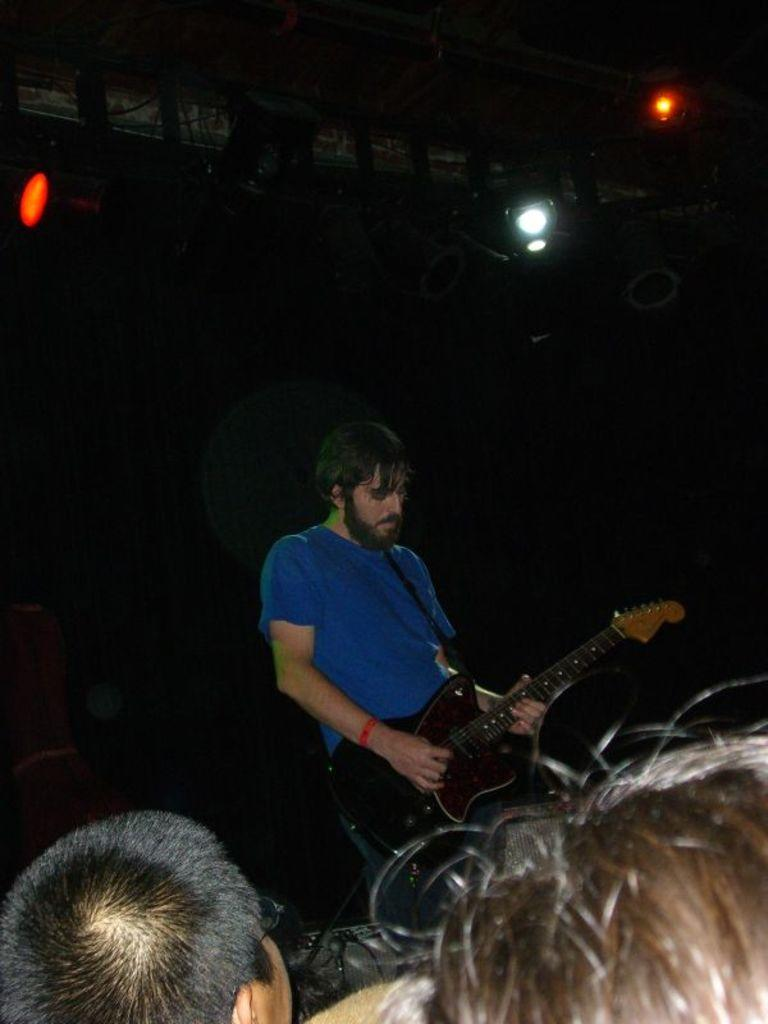What is the person in the image wearing? The person is wearing a blue shirt. What is the person doing in the image? The person is playing a guitar. What can be seen on the roof in the background? There are lights fitted to the roof in the background. Who else is present in the image besides the person playing the guitar? There are spectators in the image. What grade does the person playing the guitar receive for their performance in the image? There is no indication of a performance or grade in the image; it simply shows a person playing a guitar. 